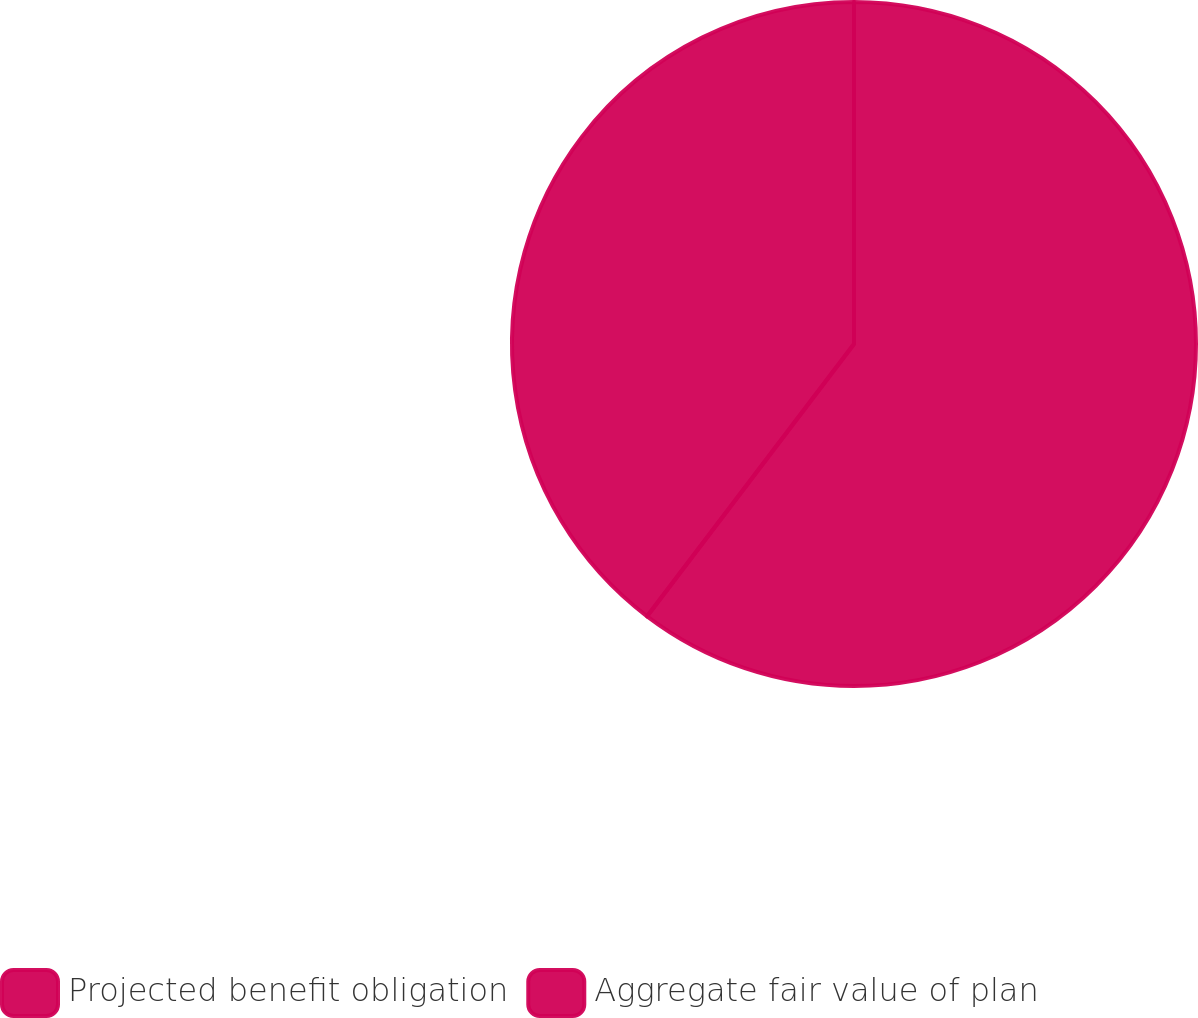Convert chart to OTSL. <chart><loc_0><loc_0><loc_500><loc_500><pie_chart><fcel>Projected benefit obligation<fcel>Aggregate fair value of plan<nl><fcel>60.34%<fcel>39.66%<nl></chart> 